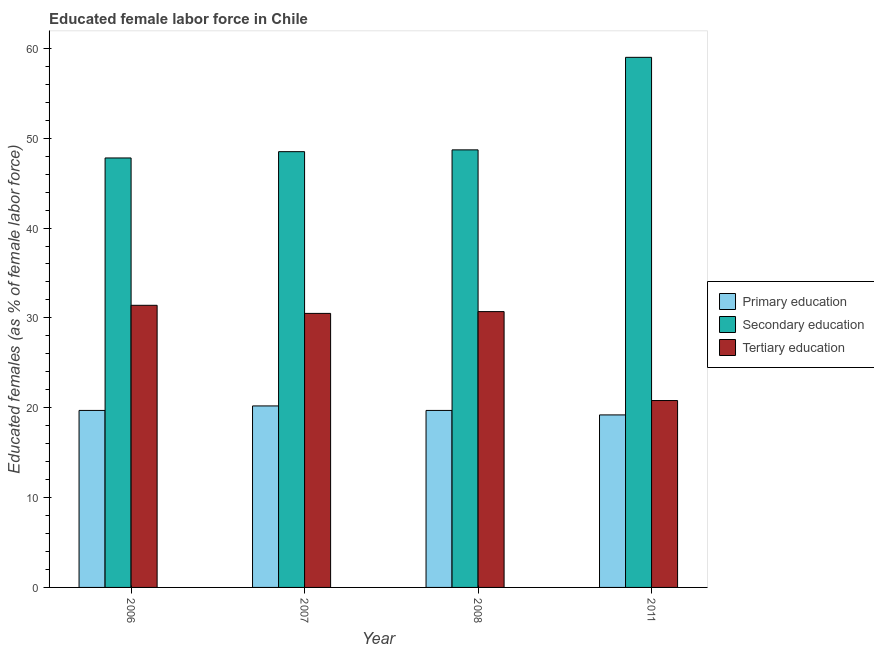Are the number of bars on each tick of the X-axis equal?
Give a very brief answer. Yes. How many bars are there on the 2nd tick from the right?
Make the answer very short. 3. What is the percentage of female labor force who received primary education in 2006?
Your response must be concise. 19.7. Across all years, what is the minimum percentage of female labor force who received primary education?
Give a very brief answer. 19.2. In which year was the percentage of female labor force who received tertiary education maximum?
Ensure brevity in your answer.  2006. In which year was the percentage of female labor force who received tertiary education minimum?
Provide a short and direct response. 2011. What is the total percentage of female labor force who received tertiary education in the graph?
Your response must be concise. 113.4. What is the difference between the percentage of female labor force who received secondary education in 2006 and that in 2011?
Your answer should be compact. -11.2. What is the difference between the percentage of female labor force who received secondary education in 2011 and the percentage of female labor force who received primary education in 2008?
Provide a short and direct response. 10.3. What is the average percentage of female labor force who received primary education per year?
Give a very brief answer. 19.7. In the year 2008, what is the difference between the percentage of female labor force who received secondary education and percentage of female labor force who received primary education?
Provide a short and direct response. 0. What is the ratio of the percentage of female labor force who received primary education in 2008 to that in 2011?
Offer a terse response. 1.03. Is the percentage of female labor force who received primary education in 2006 less than that in 2008?
Your answer should be very brief. No. What is the difference between the highest and the second highest percentage of female labor force who received secondary education?
Keep it short and to the point. 10.3. What is the difference between the highest and the lowest percentage of female labor force who received tertiary education?
Your answer should be very brief. 10.6. Is the sum of the percentage of female labor force who received primary education in 2006 and 2007 greater than the maximum percentage of female labor force who received secondary education across all years?
Make the answer very short. Yes. What does the 2nd bar from the left in 2006 represents?
Keep it short and to the point. Secondary education. What does the 1st bar from the right in 2011 represents?
Your answer should be very brief. Tertiary education. Is it the case that in every year, the sum of the percentage of female labor force who received primary education and percentage of female labor force who received secondary education is greater than the percentage of female labor force who received tertiary education?
Provide a succinct answer. Yes. Are all the bars in the graph horizontal?
Provide a short and direct response. No. Are the values on the major ticks of Y-axis written in scientific E-notation?
Offer a terse response. No. Does the graph contain any zero values?
Offer a terse response. No. Where does the legend appear in the graph?
Provide a short and direct response. Center right. How many legend labels are there?
Your answer should be very brief. 3. How are the legend labels stacked?
Provide a succinct answer. Vertical. What is the title of the graph?
Make the answer very short. Educated female labor force in Chile. What is the label or title of the Y-axis?
Make the answer very short. Educated females (as % of female labor force). What is the Educated females (as % of female labor force) of Primary education in 2006?
Ensure brevity in your answer.  19.7. What is the Educated females (as % of female labor force) in Secondary education in 2006?
Keep it short and to the point. 47.8. What is the Educated females (as % of female labor force) in Tertiary education in 2006?
Keep it short and to the point. 31.4. What is the Educated females (as % of female labor force) in Primary education in 2007?
Provide a short and direct response. 20.2. What is the Educated females (as % of female labor force) of Secondary education in 2007?
Your response must be concise. 48.5. What is the Educated females (as % of female labor force) of Tertiary education in 2007?
Offer a terse response. 30.5. What is the Educated females (as % of female labor force) in Primary education in 2008?
Keep it short and to the point. 19.7. What is the Educated females (as % of female labor force) of Secondary education in 2008?
Ensure brevity in your answer.  48.7. What is the Educated females (as % of female labor force) in Tertiary education in 2008?
Your response must be concise. 30.7. What is the Educated females (as % of female labor force) in Primary education in 2011?
Keep it short and to the point. 19.2. What is the Educated females (as % of female labor force) in Tertiary education in 2011?
Your answer should be very brief. 20.8. Across all years, what is the maximum Educated females (as % of female labor force) of Primary education?
Provide a short and direct response. 20.2. Across all years, what is the maximum Educated females (as % of female labor force) of Secondary education?
Offer a very short reply. 59. Across all years, what is the maximum Educated females (as % of female labor force) of Tertiary education?
Ensure brevity in your answer.  31.4. Across all years, what is the minimum Educated females (as % of female labor force) of Primary education?
Ensure brevity in your answer.  19.2. Across all years, what is the minimum Educated females (as % of female labor force) in Secondary education?
Your answer should be very brief. 47.8. Across all years, what is the minimum Educated females (as % of female labor force) in Tertiary education?
Make the answer very short. 20.8. What is the total Educated females (as % of female labor force) of Primary education in the graph?
Ensure brevity in your answer.  78.8. What is the total Educated females (as % of female labor force) of Secondary education in the graph?
Provide a succinct answer. 204. What is the total Educated females (as % of female labor force) of Tertiary education in the graph?
Make the answer very short. 113.4. What is the difference between the Educated females (as % of female labor force) of Tertiary education in 2006 and that in 2007?
Provide a succinct answer. 0.9. What is the difference between the Educated females (as % of female labor force) in Primary education in 2006 and that in 2008?
Offer a terse response. 0. What is the difference between the Educated females (as % of female labor force) in Tertiary education in 2006 and that in 2008?
Your answer should be very brief. 0.7. What is the difference between the Educated females (as % of female labor force) in Primary education in 2006 and that in 2011?
Provide a short and direct response. 0.5. What is the difference between the Educated females (as % of female labor force) of Primary education in 2007 and that in 2008?
Offer a very short reply. 0.5. What is the difference between the Educated females (as % of female labor force) in Secondary education in 2007 and that in 2008?
Provide a succinct answer. -0.2. What is the difference between the Educated females (as % of female labor force) of Primary education in 2007 and that in 2011?
Your answer should be very brief. 1. What is the difference between the Educated females (as % of female labor force) in Secondary education in 2007 and that in 2011?
Keep it short and to the point. -10.5. What is the difference between the Educated females (as % of female labor force) of Primary education in 2008 and that in 2011?
Give a very brief answer. 0.5. What is the difference between the Educated females (as % of female labor force) in Secondary education in 2008 and that in 2011?
Offer a terse response. -10.3. What is the difference between the Educated females (as % of female labor force) in Tertiary education in 2008 and that in 2011?
Offer a terse response. 9.9. What is the difference between the Educated females (as % of female labor force) of Primary education in 2006 and the Educated females (as % of female labor force) of Secondary education in 2007?
Keep it short and to the point. -28.8. What is the difference between the Educated females (as % of female labor force) of Secondary education in 2006 and the Educated females (as % of female labor force) of Tertiary education in 2007?
Ensure brevity in your answer.  17.3. What is the difference between the Educated females (as % of female labor force) of Primary education in 2006 and the Educated females (as % of female labor force) of Secondary education in 2011?
Your answer should be compact. -39.3. What is the difference between the Educated females (as % of female labor force) in Secondary education in 2006 and the Educated females (as % of female labor force) in Tertiary education in 2011?
Your answer should be very brief. 27. What is the difference between the Educated females (as % of female labor force) of Primary education in 2007 and the Educated females (as % of female labor force) of Secondary education in 2008?
Offer a terse response. -28.5. What is the difference between the Educated females (as % of female labor force) of Primary education in 2007 and the Educated females (as % of female labor force) of Secondary education in 2011?
Your response must be concise. -38.8. What is the difference between the Educated females (as % of female labor force) in Primary education in 2007 and the Educated females (as % of female labor force) in Tertiary education in 2011?
Give a very brief answer. -0.6. What is the difference between the Educated females (as % of female labor force) in Secondary education in 2007 and the Educated females (as % of female labor force) in Tertiary education in 2011?
Your answer should be very brief. 27.7. What is the difference between the Educated females (as % of female labor force) of Primary education in 2008 and the Educated females (as % of female labor force) of Secondary education in 2011?
Give a very brief answer. -39.3. What is the difference between the Educated females (as % of female labor force) in Secondary education in 2008 and the Educated females (as % of female labor force) in Tertiary education in 2011?
Your answer should be very brief. 27.9. What is the average Educated females (as % of female labor force) in Secondary education per year?
Your response must be concise. 51. What is the average Educated females (as % of female labor force) in Tertiary education per year?
Make the answer very short. 28.35. In the year 2006, what is the difference between the Educated females (as % of female labor force) in Primary education and Educated females (as % of female labor force) in Secondary education?
Offer a terse response. -28.1. In the year 2006, what is the difference between the Educated females (as % of female labor force) of Primary education and Educated females (as % of female labor force) of Tertiary education?
Provide a short and direct response. -11.7. In the year 2007, what is the difference between the Educated females (as % of female labor force) in Primary education and Educated females (as % of female labor force) in Secondary education?
Keep it short and to the point. -28.3. In the year 2007, what is the difference between the Educated females (as % of female labor force) in Primary education and Educated females (as % of female labor force) in Tertiary education?
Offer a terse response. -10.3. In the year 2008, what is the difference between the Educated females (as % of female labor force) in Primary education and Educated females (as % of female labor force) in Secondary education?
Ensure brevity in your answer.  -29. In the year 2011, what is the difference between the Educated females (as % of female labor force) of Primary education and Educated females (as % of female labor force) of Secondary education?
Your response must be concise. -39.8. In the year 2011, what is the difference between the Educated females (as % of female labor force) in Secondary education and Educated females (as % of female labor force) in Tertiary education?
Provide a succinct answer. 38.2. What is the ratio of the Educated females (as % of female labor force) in Primary education in 2006 to that in 2007?
Keep it short and to the point. 0.98. What is the ratio of the Educated females (as % of female labor force) of Secondary education in 2006 to that in 2007?
Offer a terse response. 0.99. What is the ratio of the Educated females (as % of female labor force) in Tertiary education in 2006 to that in 2007?
Offer a very short reply. 1.03. What is the ratio of the Educated females (as % of female labor force) in Primary education in 2006 to that in 2008?
Ensure brevity in your answer.  1. What is the ratio of the Educated females (as % of female labor force) in Secondary education in 2006 to that in 2008?
Your answer should be compact. 0.98. What is the ratio of the Educated females (as % of female labor force) of Tertiary education in 2006 to that in 2008?
Give a very brief answer. 1.02. What is the ratio of the Educated females (as % of female labor force) in Primary education in 2006 to that in 2011?
Give a very brief answer. 1.03. What is the ratio of the Educated females (as % of female labor force) in Secondary education in 2006 to that in 2011?
Offer a terse response. 0.81. What is the ratio of the Educated females (as % of female labor force) in Tertiary education in 2006 to that in 2011?
Offer a terse response. 1.51. What is the ratio of the Educated females (as % of female labor force) in Primary education in 2007 to that in 2008?
Make the answer very short. 1.03. What is the ratio of the Educated females (as % of female labor force) of Secondary education in 2007 to that in 2008?
Give a very brief answer. 1. What is the ratio of the Educated females (as % of female labor force) in Tertiary education in 2007 to that in 2008?
Make the answer very short. 0.99. What is the ratio of the Educated females (as % of female labor force) in Primary education in 2007 to that in 2011?
Keep it short and to the point. 1.05. What is the ratio of the Educated females (as % of female labor force) in Secondary education in 2007 to that in 2011?
Your response must be concise. 0.82. What is the ratio of the Educated females (as % of female labor force) in Tertiary education in 2007 to that in 2011?
Give a very brief answer. 1.47. What is the ratio of the Educated females (as % of female labor force) of Primary education in 2008 to that in 2011?
Make the answer very short. 1.03. What is the ratio of the Educated females (as % of female labor force) of Secondary education in 2008 to that in 2011?
Give a very brief answer. 0.83. What is the ratio of the Educated females (as % of female labor force) in Tertiary education in 2008 to that in 2011?
Provide a short and direct response. 1.48. What is the difference between the highest and the second highest Educated females (as % of female labor force) in Primary education?
Give a very brief answer. 0.5. What is the difference between the highest and the lowest Educated females (as % of female labor force) in Primary education?
Offer a very short reply. 1. What is the difference between the highest and the lowest Educated females (as % of female labor force) in Tertiary education?
Keep it short and to the point. 10.6. 